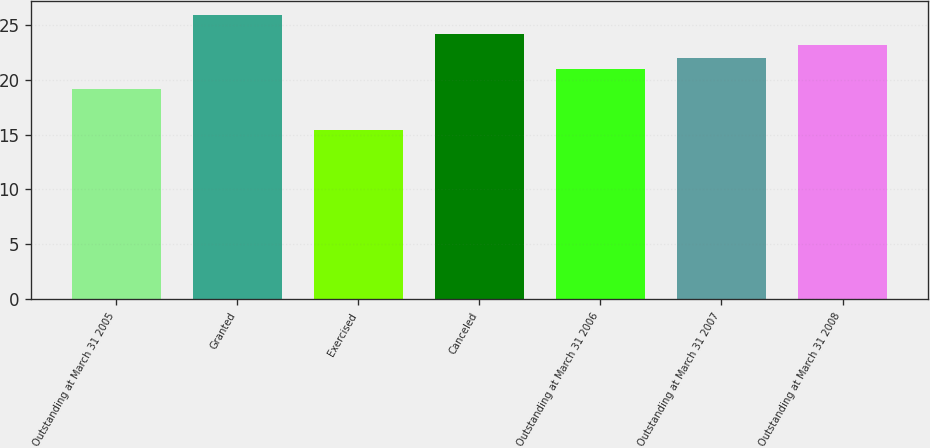Convert chart to OTSL. <chart><loc_0><loc_0><loc_500><loc_500><bar_chart><fcel>Outstanding at March 31 2005<fcel>Granted<fcel>Exercised<fcel>Canceled<fcel>Outstanding at March 31 2006<fcel>Outstanding at March 31 2007<fcel>Outstanding at March 31 2008<nl><fcel>19.19<fcel>25.91<fcel>15.46<fcel>24.19<fcel>20.97<fcel>22.02<fcel>23.14<nl></chart> 